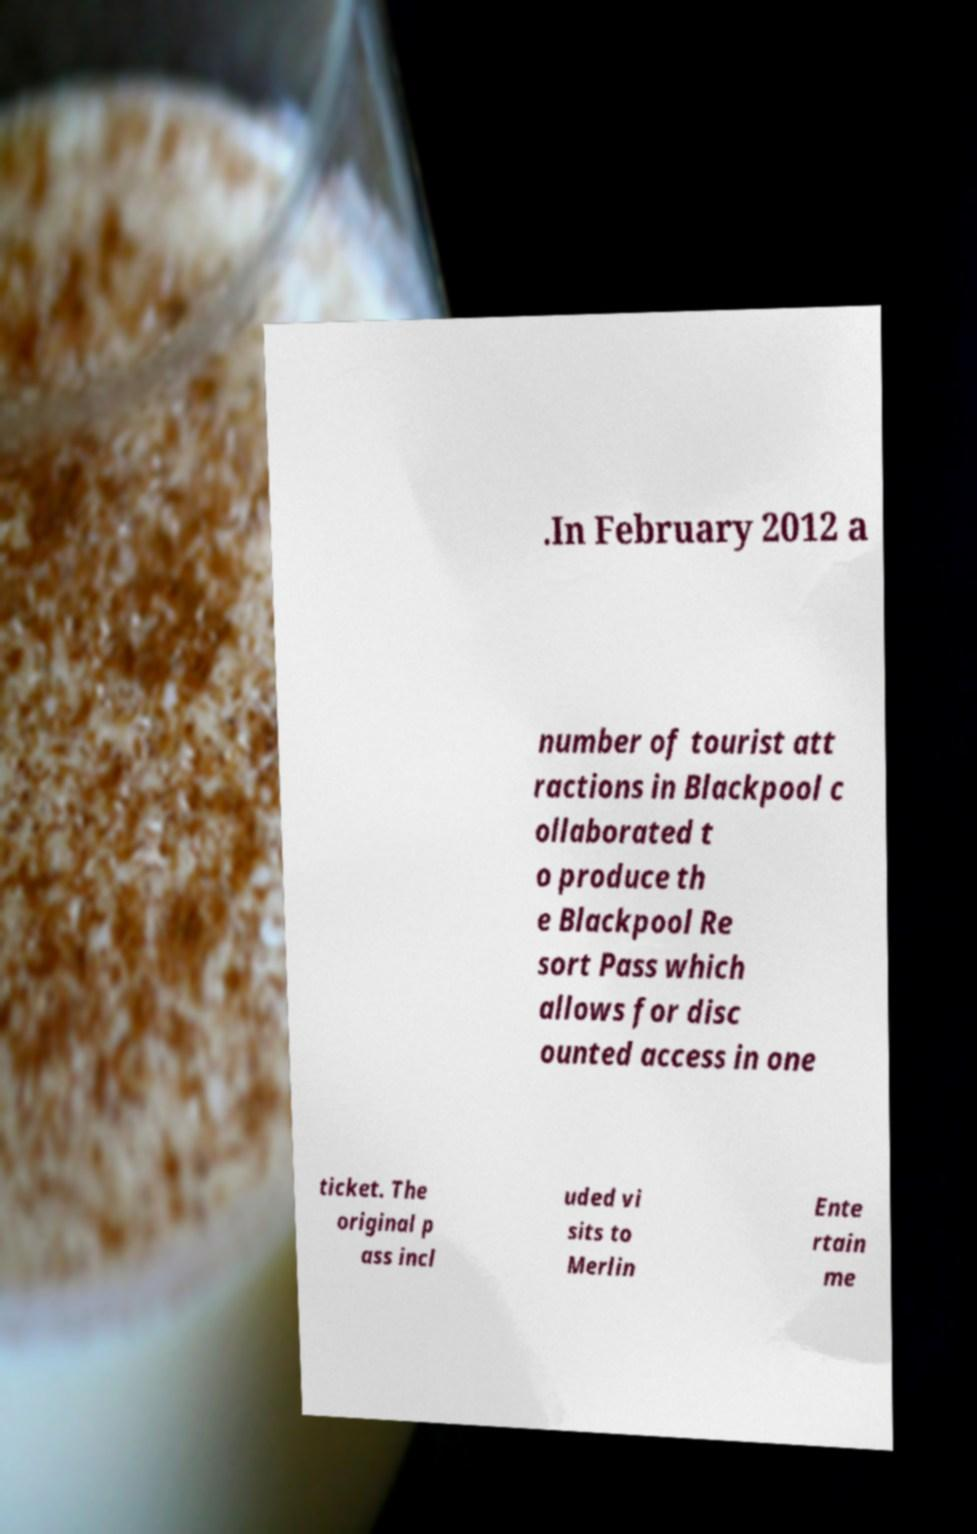Could you extract and type out the text from this image? .In February 2012 a number of tourist att ractions in Blackpool c ollaborated t o produce th e Blackpool Re sort Pass which allows for disc ounted access in one ticket. The original p ass incl uded vi sits to Merlin Ente rtain me 